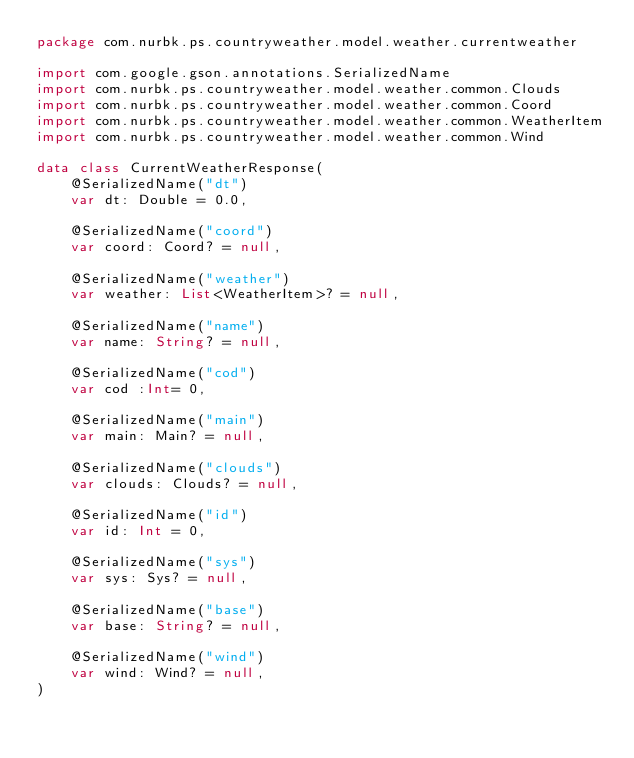<code> <loc_0><loc_0><loc_500><loc_500><_Kotlin_>package com.nurbk.ps.countryweather.model.weather.currentweather

import com.google.gson.annotations.SerializedName
import com.nurbk.ps.countryweather.model.weather.common.Clouds
import com.nurbk.ps.countryweather.model.weather.common.Coord
import com.nurbk.ps.countryweather.model.weather.common.WeatherItem
import com.nurbk.ps.countryweather.model.weather.common.Wind

data class CurrentWeatherResponse(
    @SerializedName("dt")
    var dt: Double = 0.0,

    @SerializedName("coord")
    var coord: Coord? = null,

    @SerializedName("weather")
    var weather: List<WeatherItem>? = null,

    @SerializedName("name")
    var name: String? = null,

    @SerializedName("cod")
    var cod :Int= 0,

    @SerializedName("main")
    var main: Main? = null,

    @SerializedName("clouds")
    var clouds: Clouds? = null,

    @SerializedName("id")
    var id: Int = 0,

    @SerializedName("sys")
    var sys: Sys? = null,

    @SerializedName("base")
    var base: String? = null,

    @SerializedName("wind")
    var wind: Wind? = null,
)</code> 